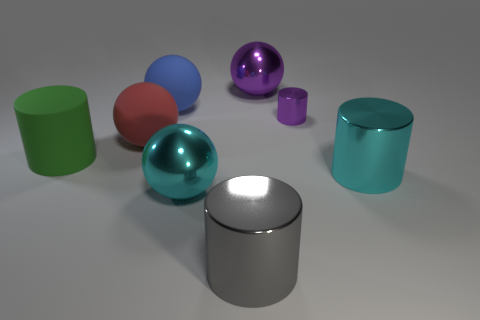Subtract all gray metal cylinders. How many cylinders are left? 3 Subtract 2 cylinders. How many cylinders are left? 2 Subtract all red spheres. How many spheres are left? 3 Add 1 matte spheres. How many objects exist? 9 Subtract all brown spheres. Subtract all yellow cylinders. How many spheres are left? 4 Subtract all big cyan metallic things. Subtract all rubber objects. How many objects are left? 3 Add 4 red matte objects. How many red matte objects are left? 5 Add 4 big gray things. How many big gray things exist? 5 Subtract 1 blue balls. How many objects are left? 7 